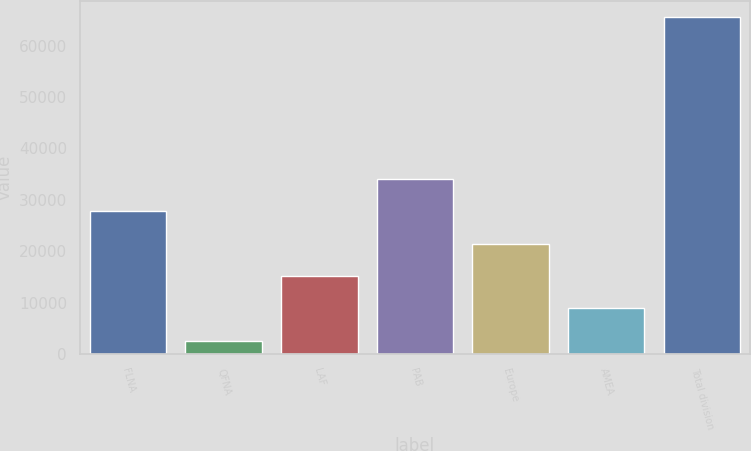<chart> <loc_0><loc_0><loc_500><loc_500><bar_chart><fcel>FLNA<fcel>QFNA<fcel>LAF<fcel>PAB<fcel>Europe<fcel>AMEA<fcel>Total division<nl><fcel>27778.4<fcel>2636<fcel>15207.2<fcel>34064<fcel>21492.8<fcel>8921.6<fcel>65492<nl></chart> 